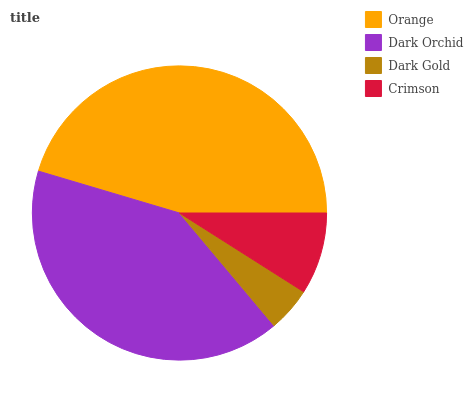Is Dark Gold the minimum?
Answer yes or no. Yes. Is Orange the maximum?
Answer yes or no. Yes. Is Dark Orchid the minimum?
Answer yes or no. No. Is Dark Orchid the maximum?
Answer yes or no. No. Is Orange greater than Dark Orchid?
Answer yes or no. Yes. Is Dark Orchid less than Orange?
Answer yes or no. Yes. Is Dark Orchid greater than Orange?
Answer yes or no. No. Is Orange less than Dark Orchid?
Answer yes or no. No. Is Dark Orchid the high median?
Answer yes or no. Yes. Is Crimson the low median?
Answer yes or no. Yes. Is Orange the high median?
Answer yes or no. No. Is Dark Orchid the low median?
Answer yes or no. No. 